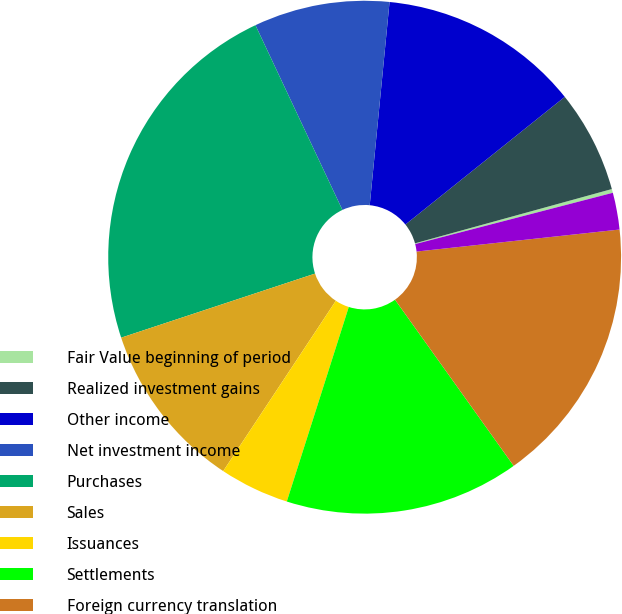Convert chart. <chart><loc_0><loc_0><loc_500><loc_500><pie_chart><fcel>Fair Value beginning of period<fcel>Realized investment gains<fcel>Other income<fcel>Net investment income<fcel>Purchases<fcel>Sales<fcel>Issuances<fcel>Settlements<fcel>Foreign currency translation<fcel>Other(1)<nl><fcel>0.24%<fcel>6.47%<fcel>12.7%<fcel>8.55%<fcel>23.08%<fcel>10.62%<fcel>4.39%<fcel>14.78%<fcel>16.85%<fcel>2.32%<nl></chart> 